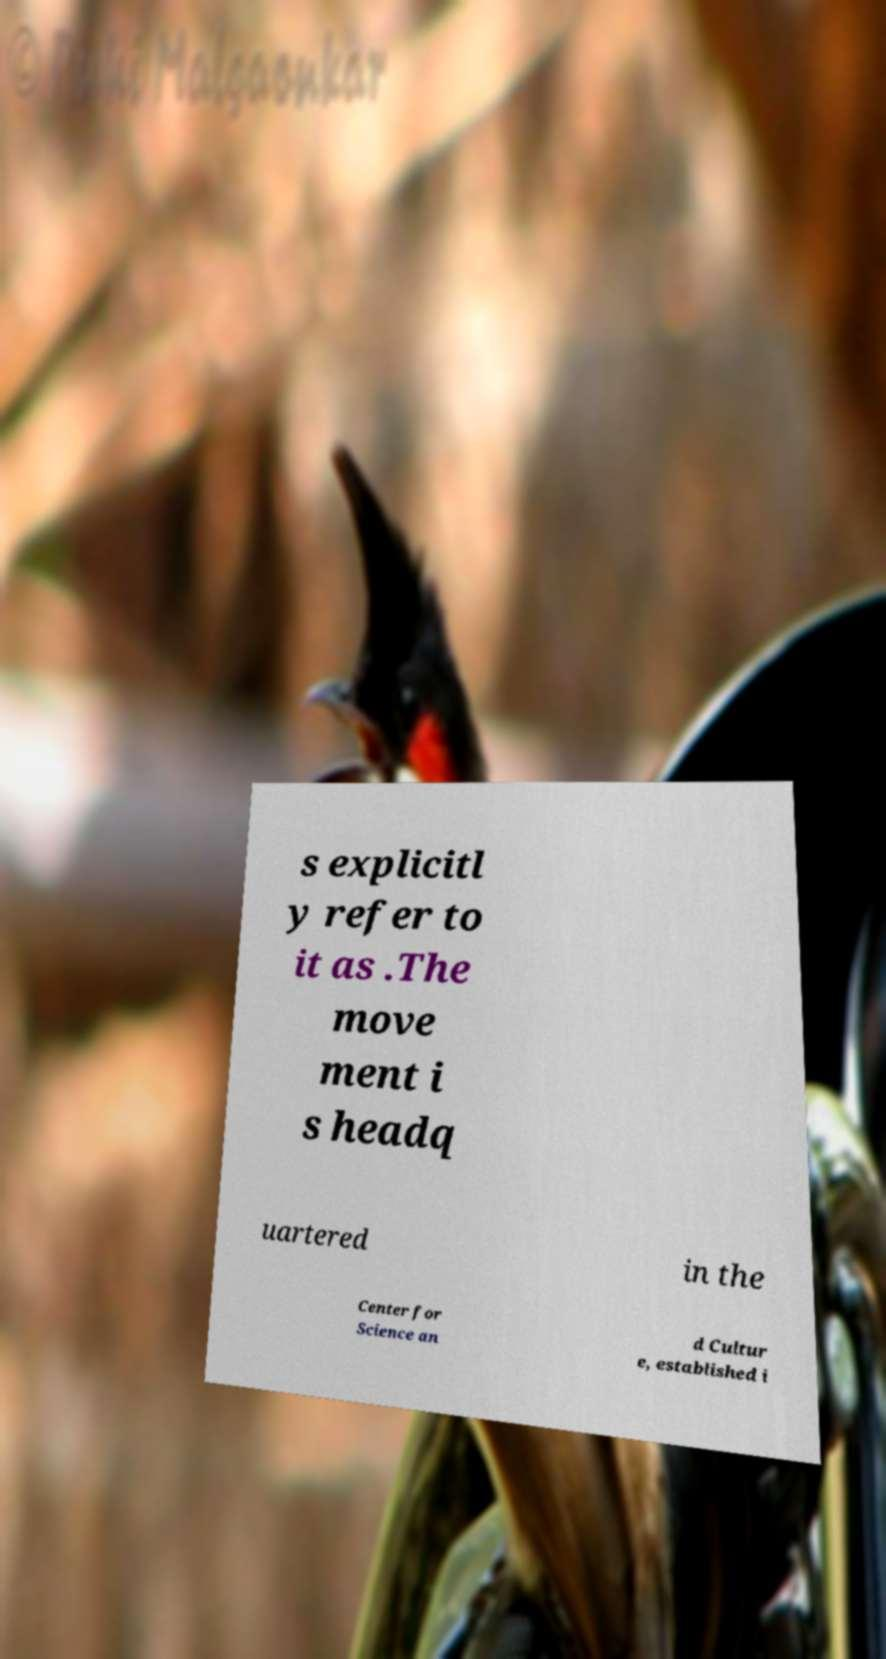Can you accurately transcribe the text from the provided image for me? s explicitl y refer to it as .The move ment i s headq uartered in the Center for Science an d Cultur e, established i 